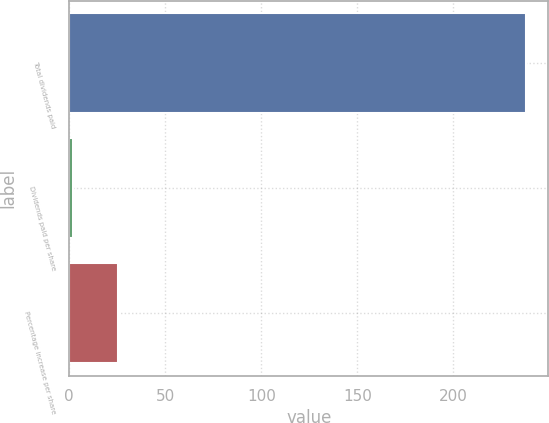Convert chart. <chart><loc_0><loc_0><loc_500><loc_500><bar_chart><fcel>Total dividends paid<fcel>Dividends paid per share<fcel>Percentage increase per share<nl><fcel>237.6<fcel>1.88<fcel>25.45<nl></chart> 